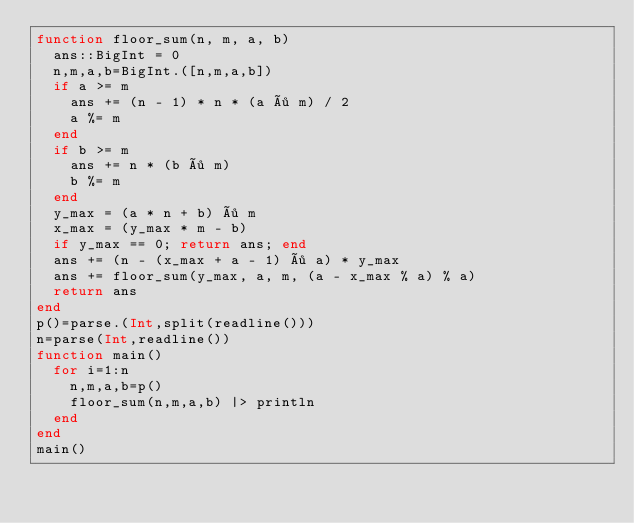<code> <loc_0><loc_0><loc_500><loc_500><_Julia_>function floor_sum(n, m, a, b)
  ans::BigInt = 0
  n,m,a,b=BigInt.([n,m,a,b])
  if a >= m
    ans += (n - 1) * n * (a ÷ m) / 2
    a %= m
  end
  if b >= m
    ans += n * (b ÷ m)
    b %= m
  end
  y_max = (a * n + b) ÷ m
  x_max = (y_max * m - b)
  if y_max == 0; return ans; end
  ans += (n - (x_max + a - 1) ÷ a) * y_max
  ans += floor_sum(y_max, a, m, (a - x_max % a) % a)
  return ans
end
p()=parse.(Int,split(readline()))
n=parse(Int,readline())
function main()
  for i=1:n
    n,m,a,b=p()
    floor_sum(n,m,a,b) |> println
  end
end
main()</code> 